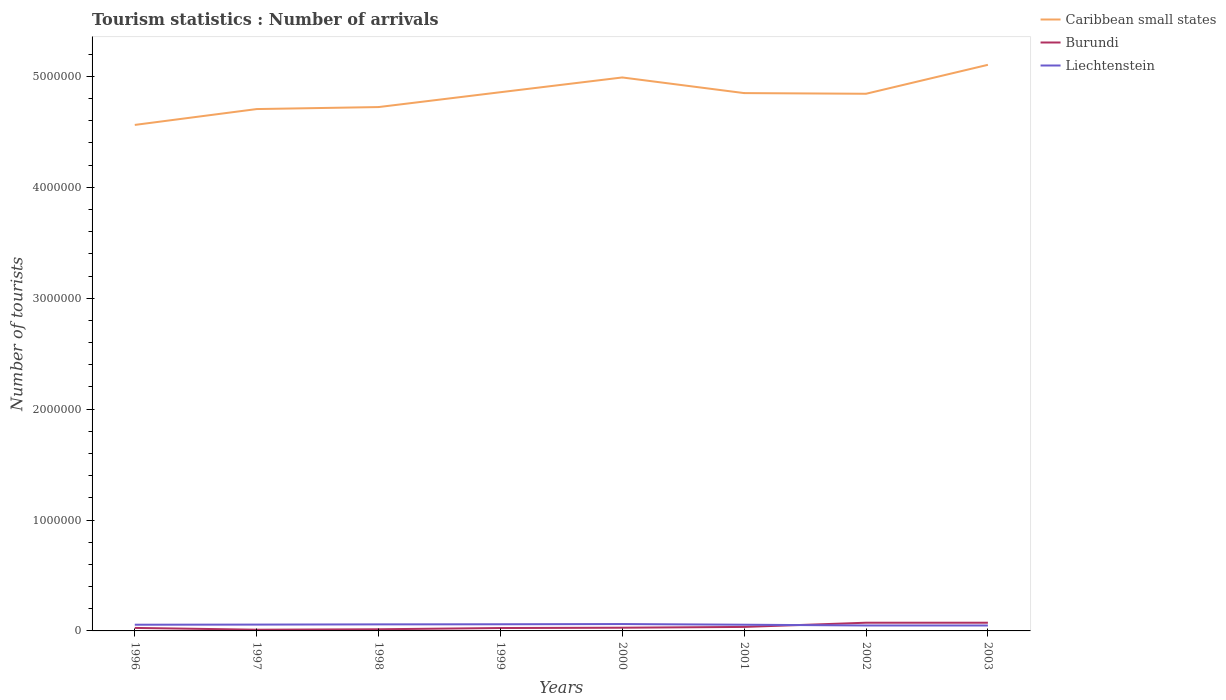How many different coloured lines are there?
Provide a short and direct response. 3. Does the line corresponding to Liechtenstein intersect with the line corresponding to Burundi?
Your answer should be compact. Yes. Across all years, what is the maximum number of tourist arrivals in Caribbean small states?
Provide a succinct answer. 4.56e+06. In which year was the number of tourist arrivals in Burundi maximum?
Provide a short and direct response. 1997. What is the total number of tourist arrivals in Burundi in the graph?
Give a very brief answer. -2000. What is the difference between the highest and the second highest number of tourist arrivals in Liechtenstein?
Offer a terse response. 1.30e+04. How many years are there in the graph?
Ensure brevity in your answer.  8. Does the graph contain grids?
Make the answer very short. No. Where does the legend appear in the graph?
Your answer should be compact. Top right. How many legend labels are there?
Offer a terse response. 3. How are the legend labels stacked?
Offer a very short reply. Vertical. What is the title of the graph?
Provide a succinct answer. Tourism statistics : Number of arrivals. Does "Comoros" appear as one of the legend labels in the graph?
Ensure brevity in your answer.  No. What is the label or title of the Y-axis?
Make the answer very short. Number of tourists. What is the Number of tourists of Caribbean small states in 1996?
Keep it short and to the point. 4.56e+06. What is the Number of tourists in Burundi in 1996?
Your answer should be very brief. 2.70e+04. What is the Number of tourists of Liechtenstein in 1996?
Offer a terse response. 5.60e+04. What is the Number of tourists of Caribbean small states in 1997?
Offer a very short reply. 4.71e+06. What is the Number of tourists in Burundi in 1997?
Ensure brevity in your answer.  1.10e+04. What is the Number of tourists in Liechtenstein in 1997?
Provide a succinct answer. 5.70e+04. What is the Number of tourists in Caribbean small states in 1998?
Offer a terse response. 4.72e+06. What is the Number of tourists in Burundi in 1998?
Your response must be concise. 1.50e+04. What is the Number of tourists in Liechtenstein in 1998?
Your response must be concise. 5.90e+04. What is the Number of tourists of Caribbean small states in 1999?
Your response must be concise. 4.86e+06. What is the Number of tourists in Burundi in 1999?
Make the answer very short. 2.60e+04. What is the Number of tourists of Liechtenstein in 1999?
Provide a succinct answer. 6.00e+04. What is the Number of tourists in Caribbean small states in 2000?
Make the answer very short. 4.99e+06. What is the Number of tourists in Burundi in 2000?
Provide a short and direct response. 2.90e+04. What is the Number of tourists in Liechtenstein in 2000?
Give a very brief answer. 6.20e+04. What is the Number of tourists in Caribbean small states in 2001?
Your response must be concise. 4.85e+06. What is the Number of tourists of Burundi in 2001?
Provide a succinct answer. 3.60e+04. What is the Number of tourists in Liechtenstein in 2001?
Keep it short and to the point. 5.60e+04. What is the Number of tourists in Caribbean small states in 2002?
Provide a short and direct response. 4.84e+06. What is the Number of tourists of Burundi in 2002?
Offer a terse response. 7.40e+04. What is the Number of tourists in Liechtenstein in 2002?
Your answer should be compact. 4.90e+04. What is the Number of tourists of Caribbean small states in 2003?
Provide a short and direct response. 5.10e+06. What is the Number of tourists of Burundi in 2003?
Provide a short and direct response. 7.40e+04. What is the Number of tourists in Liechtenstein in 2003?
Give a very brief answer. 4.90e+04. Across all years, what is the maximum Number of tourists of Caribbean small states?
Ensure brevity in your answer.  5.10e+06. Across all years, what is the maximum Number of tourists in Burundi?
Provide a short and direct response. 7.40e+04. Across all years, what is the maximum Number of tourists in Liechtenstein?
Offer a terse response. 6.20e+04. Across all years, what is the minimum Number of tourists of Caribbean small states?
Your answer should be very brief. 4.56e+06. Across all years, what is the minimum Number of tourists in Burundi?
Keep it short and to the point. 1.10e+04. Across all years, what is the minimum Number of tourists in Liechtenstein?
Give a very brief answer. 4.90e+04. What is the total Number of tourists of Caribbean small states in the graph?
Give a very brief answer. 3.86e+07. What is the total Number of tourists in Burundi in the graph?
Offer a very short reply. 2.92e+05. What is the total Number of tourists in Liechtenstein in the graph?
Give a very brief answer. 4.48e+05. What is the difference between the Number of tourists in Caribbean small states in 1996 and that in 1997?
Offer a terse response. -1.43e+05. What is the difference between the Number of tourists in Burundi in 1996 and that in 1997?
Your response must be concise. 1.60e+04. What is the difference between the Number of tourists in Liechtenstein in 1996 and that in 1997?
Provide a succinct answer. -1000. What is the difference between the Number of tourists in Caribbean small states in 1996 and that in 1998?
Offer a very short reply. -1.61e+05. What is the difference between the Number of tourists of Burundi in 1996 and that in 1998?
Provide a succinct answer. 1.20e+04. What is the difference between the Number of tourists in Liechtenstein in 1996 and that in 1998?
Give a very brief answer. -3000. What is the difference between the Number of tourists of Caribbean small states in 1996 and that in 1999?
Your response must be concise. -2.95e+05. What is the difference between the Number of tourists of Burundi in 1996 and that in 1999?
Keep it short and to the point. 1000. What is the difference between the Number of tourists of Liechtenstein in 1996 and that in 1999?
Provide a short and direct response. -4000. What is the difference between the Number of tourists of Caribbean small states in 1996 and that in 2000?
Give a very brief answer. -4.28e+05. What is the difference between the Number of tourists of Burundi in 1996 and that in 2000?
Make the answer very short. -2000. What is the difference between the Number of tourists of Liechtenstein in 1996 and that in 2000?
Your response must be concise. -6000. What is the difference between the Number of tourists of Caribbean small states in 1996 and that in 2001?
Give a very brief answer. -2.87e+05. What is the difference between the Number of tourists of Burundi in 1996 and that in 2001?
Keep it short and to the point. -9000. What is the difference between the Number of tourists in Caribbean small states in 1996 and that in 2002?
Give a very brief answer. -2.81e+05. What is the difference between the Number of tourists of Burundi in 1996 and that in 2002?
Ensure brevity in your answer.  -4.70e+04. What is the difference between the Number of tourists of Liechtenstein in 1996 and that in 2002?
Provide a succinct answer. 7000. What is the difference between the Number of tourists of Caribbean small states in 1996 and that in 2003?
Ensure brevity in your answer.  -5.42e+05. What is the difference between the Number of tourists in Burundi in 1996 and that in 2003?
Provide a succinct answer. -4.70e+04. What is the difference between the Number of tourists of Liechtenstein in 1996 and that in 2003?
Provide a succinct answer. 7000. What is the difference between the Number of tourists of Caribbean small states in 1997 and that in 1998?
Keep it short and to the point. -1.80e+04. What is the difference between the Number of tourists in Burundi in 1997 and that in 1998?
Your response must be concise. -4000. What is the difference between the Number of tourists in Liechtenstein in 1997 and that in 1998?
Provide a succinct answer. -2000. What is the difference between the Number of tourists in Caribbean small states in 1997 and that in 1999?
Offer a terse response. -1.52e+05. What is the difference between the Number of tourists in Burundi in 1997 and that in 1999?
Make the answer very short. -1.50e+04. What is the difference between the Number of tourists of Liechtenstein in 1997 and that in 1999?
Keep it short and to the point. -3000. What is the difference between the Number of tourists in Caribbean small states in 1997 and that in 2000?
Keep it short and to the point. -2.85e+05. What is the difference between the Number of tourists in Burundi in 1997 and that in 2000?
Make the answer very short. -1.80e+04. What is the difference between the Number of tourists of Liechtenstein in 1997 and that in 2000?
Your response must be concise. -5000. What is the difference between the Number of tourists in Caribbean small states in 1997 and that in 2001?
Offer a terse response. -1.44e+05. What is the difference between the Number of tourists in Burundi in 1997 and that in 2001?
Offer a terse response. -2.50e+04. What is the difference between the Number of tourists in Caribbean small states in 1997 and that in 2002?
Offer a very short reply. -1.38e+05. What is the difference between the Number of tourists of Burundi in 1997 and that in 2002?
Give a very brief answer. -6.30e+04. What is the difference between the Number of tourists of Liechtenstein in 1997 and that in 2002?
Give a very brief answer. 8000. What is the difference between the Number of tourists in Caribbean small states in 1997 and that in 2003?
Your answer should be compact. -3.99e+05. What is the difference between the Number of tourists of Burundi in 1997 and that in 2003?
Make the answer very short. -6.30e+04. What is the difference between the Number of tourists in Liechtenstein in 1997 and that in 2003?
Your answer should be very brief. 8000. What is the difference between the Number of tourists of Caribbean small states in 1998 and that in 1999?
Your answer should be compact. -1.34e+05. What is the difference between the Number of tourists of Burundi in 1998 and that in 1999?
Provide a succinct answer. -1.10e+04. What is the difference between the Number of tourists in Liechtenstein in 1998 and that in 1999?
Ensure brevity in your answer.  -1000. What is the difference between the Number of tourists in Caribbean small states in 1998 and that in 2000?
Give a very brief answer. -2.67e+05. What is the difference between the Number of tourists of Burundi in 1998 and that in 2000?
Give a very brief answer. -1.40e+04. What is the difference between the Number of tourists of Liechtenstein in 1998 and that in 2000?
Your response must be concise. -3000. What is the difference between the Number of tourists of Caribbean small states in 1998 and that in 2001?
Your response must be concise. -1.26e+05. What is the difference between the Number of tourists in Burundi in 1998 and that in 2001?
Give a very brief answer. -2.10e+04. What is the difference between the Number of tourists of Liechtenstein in 1998 and that in 2001?
Your response must be concise. 3000. What is the difference between the Number of tourists of Burundi in 1998 and that in 2002?
Provide a short and direct response. -5.90e+04. What is the difference between the Number of tourists of Liechtenstein in 1998 and that in 2002?
Make the answer very short. 10000. What is the difference between the Number of tourists in Caribbean small states in 1998 and that in 2003?
Provide a short and direct response. -3.81e+05. What is the difference between the Number of tourists in Burundi in 1998 and that in 2003?
Your response must be concise. -5.90e+04. What is the difference between the Number of tourists in Caribbean small states in 1999 and that in 2000?
Offer a very short reply. -1.33e+05. What is the difference between the Number of tourists in Burundi in 1999 and that in 2000?
Offer a very short reply. -3000. What is the difference between the Number of tourists in Liechtenstein in 1999 and that in 2000?
Provide a short and direct response. -2000. What is the difference between the Number of tourists of Caribbean small states in 1999 and that in 2001?
Ensure brevity in your answer.  8000. What is the difference between the Number of tourists of Liechtenstein in 1999 and that in 2001?
Offer a terse response. 4000. What is the difference between the Number of tourists of Caribbean small states in 1999 and that in 2002?
Offer a terse response. 1.40e+04. What is the difference between the Number of tourists of Burundi in 1999 and that in 2002?
Make the answer very short. -4.80e+04. What is the difference between the Number of tourists in Liechtenstein in 1999 and that in 2002?
Your answer should be compact. 1.10e+04. What is the difference between the Number of tourists of Caribbean small states in 1999 and that in 2003?
Offer a terse response. -2.47e+05. What is the difference between the Number of tourists of Burundi in 1999 and that in 2003?
Provide a succinct answer. -4.80e+04. What is the difference between the Number of tourists in Liechtenstein in 1999 and that in 2003?
Provide a succinct answer. 1.10e+04. What is the difference between the Number of tourists of Caribbean small states in 2000 and that in 2001?
Give a very brief answer. 1.41e+05. What is the difference between the Number of tourists of Burundi in 2000 and that in 2001?
Ensure brevity in your answer.  -7000. What is the difference between the Number of tourists of Liechtenstein in 2000 and that in 2001?
Make the answer very short. 6000. What is the difference between the Number of tourists of Caribbean small states in 2000 and that in 2002?
Provide a short and direct response. 1.47e+05. What is the difference between the Number of tourists of Burundi in 2000 and that in 2002?
Make the answer very short. -4.50e+04. What is the difference between the Number of tourists in Liechtenstein in 2000 and that in 2002?
Make the answer very short. 1.30e+04. What is the difference between the Number of tourists in Caribbean small states in 2000 and that in 2003?
Your response must be concise. -1.14e+05. What is the difference between the Number of tourists of Burundi in 2000 and that in 2003?
Your answer should be very brief. -4.50e+04. What is the difference between the Number of tourists of Liechtenstein in 2000 and that in 2003?
Offer a very short reply. 1.30e+04. What is the difference between the Number of tourists of Caribbean small states in 2001 and that in 2002?
Ensure brevity in your answer.  6000. What is the difference between the Number of tourists of Burundi in 2001 and that in 2002?
Provide a succinct answer. -3.80e+04. What is the difference between the Number of tourists in Liechtenstein in 2001 and that in 2002?
Keep it short and to the point. 7000. What is the difference between the Number of tourists of Caribbean small states in 2001 and that in 2003?
Give a very brief answer. -2.55e+05. What is the difference between the Number of tourists in Burundi in 2001 and that in 2003?
Your answer should be very brief. -3.80e+04. What is the difference between the Number of tourists of Liechtenstein in 2001 and that in 2003?
Ensure brevity in your answer.  7000. What is the difference between the Number of tourists of Caribbean small states in 2002 and that in 2003?
Provide a short and direct response. -2.61e+05. What is the difference between the Number of tourists of Burundi in 2002 and that in 2003?
Make the answer very short. 0. What is the difference between the Number of tourists in Caribbean small states in 1996 and the Number of tourists in Burundi in 1997?
Your answer should be very brief. 4.55e+06. What is the difference between the Number of tourists in Caribbean small states in 1996 and the Number of tourists in Liechtenstein in 1997?
Provide a succinct answer. 4.51e+06. What is the difference between the Number of tourists in Caribbean small states in 1996 and the Number of tourists in Burundi in 1998?
Keep it short and to the point. 4.55e+06. What is the difference between the Number of tourists of Caribbean small states in 1996 and the Number of tourists of Liechtenstein in 1998?
Your answer should be very brief. 4.50e+06. What is the difference between the Number of tourists of Burundi in 1996 and the Number of tourists of Liechtenstein in 1998?
Provide a short and direct response. -3.20e+04. What is the difference between the Number of tourists in Caribbean small states in 1996 and the Number of tourists in Burundi in 1999?
Offer a very short reply. 4.54e+06. What is the difference between the Number of tourists in Caribbean small states in 1996 and the Number of tourists in Liechtenstein in 1999?
Offer a terse response. 4.50e+06. What is the difference between the Number of tourists of Burundi in 1996 and the Number of tourists of Liechtenstein in 1999?
Your response must be concise. -3.30e+04. What is the difference between the Number of tourists of Caribbean small states in 1996 and the Number of tourists of Burundi in 2000?
Your response must be concise. 4.53e+06. What is the difference between the Number of tourists in Caribbean small states in 1996 and the Number of tourists in Liechtenstein in 2000?
Ensure brevity in your answer.  4.50e+06. What is the difference between the Number of tourists in Burundi in 1996 and the Number of tourists in Liechtenstein in 2000?
Your response must be concise. -3.50e+04. What is the difference between the Number of tourists in Caribbean small states in 1996 and the Number of tourists in Burundi in 2001?
Your response must be concise. 4.53e+06. What is the difference between the Number of tourists in Caribbean small states in 1996 and the Number of tourists in Liechtenstein in 2001?
Your response must be concise. 4.51e+06. What is the difference between the Number of tourists in Burundi in 1996 and the Number of tourists in Liechtenstein in 2001?
Your answer should be very brief. -2.90e+04. What is the difference between the Number of tourists of Caribbean small states in 1996 and the Number of tourists of Burundi in 2002?
Keep it short and to the point. 4.49e+06. What is the difference between the Number of tourists of Caribbean small states in 1996 and the Number of tourists of Liechtenstein in 2002?
Ensure brevity in your answer.  4.51e+06. What is the difference between the Number of tourists of Burundi in 1996 and the Number of tourists of Liechtenstein in 2002?
Provide a succinct answer. -2.20e+04. What is the difference between the Number of tourists of Caribbean small states in 1996 and the Number of tourists of Burundi in 2003?
Ensure brevity in your answer.  4.49e+06. What is the difference between the Number of tourists in Caribbean small states in 1996 and the Number of tourists in Liechtenstein in 2003?
Provide a succinct answer. 4.51e+06. What is the difference between the Number of tourists of Burundi in 1996 and the Number of tourists of Liechtenstein in 2003?
Your response must be concise. -2.20e+04. What is the difference between the Number of tourists in Caribbean small states in 1997 and the Number of tourists in Burundi in 1998?
Provide a succinct answer. 4.69e+06. What is the difference between the Number of tourists of Caribbean small states in 1997 and the Number of tourists of Liechtenstein in 1998?
Give a very brief answer. 4.65e+06. What is the difference between the Number of tourists in Burundi in 1997 and the Number of tourists in Liechtenstein in 1998?
Provide a succinct answer. -4.80e+04. What is the difference between the Number of tourists in Caribbean small states in 1997 and the Number of tourists in Burundi in 1999?
Your answer should be very brief. 4.68e+06. What is the difference between the Number of tourists in Caribbean small states in 1997 and the Number of tourists in Liechtenstein in 1999?
Your answer should be compact. 4.65e+06. What is the difference between the Number of tourists in Burundi in 1997 and the Number of tourists in Liechtenstein in 1999?
Provide a succinct answer. -4.90e+04. What is the difference between the Number of tourists in Caribbean small states in 1997 and the Number of tourists in Burundi in 2000?
Offer a terse response. 4.68e+06. What is the difference between the Number of tourists in Caribbean small states in 1997 and the Number of tourists in Liechtenstein in 2000?
Make the answer very short. 4.64e+06. What is the difference between the Number of tourists of Burundi in 1997 and the Number of tourists of Liechtenstein in 2000?
Offer a very short reply. -5.10e+04. What is the difference between the Number of tourists of Caribbean small states in 1997 and the Number of tourists of Burundi in 2001?
Ensure brevity in your answer.  4.67e+06. What is the difference between the Number of tourists of Caribbean small states in 1997 and the Number of tourists of Liechtenstein in 2001?
Give a very brief answer. 4.65e+06. What is the difference between the Number of tourists of Burundi in 1997 and the Number of tourists of Liechtenstein in 2001?
Ensure brevity in your answer.  -4.50e+04. What is the difference between the Number of tourists in Caribbean small states in 1997 and the Number of tourists in Burundi in 2002?
Your answer should be very brief. 4.63e+06. What is the difference between the Number of tourists in Caribbean small states in 1997 and the Number of tourists in Liechtenstein in 2002?
Offer a terse response. 4.66e+06. What is the difference between the Number of tourists in Burundi in 1997 and the Number of tourists in Liechtenstein in 2002?
Provide a short and direct response. -3.80e+04. What is the difference between the Number of tourists of Caribbean small states in 1997 and the Number of tourists of Burundi in 2003?
Give a very brief answer. 4.63e+06. What is the difference between the Number of tourists in Caribbean small states in 1997 and the Number of tourists in Liechtenstein in 2003?
Your answer should be compact. 4.66e+06. What is the difference between the Number of tourists in Burundi in 1997 and the Number of tourists in Liechtenstein in 2003?
Provide a succinct answer. -3.80e+04. What is the difference between the Number of tourists of Caribbean small states in 1998 and the Number of tourists of Burundi in 1999?
Your response must be concise. 4.70e+06. What is the difference between the Number of tourists in Caribbean small states in 1998 and the Number of tourists in Liechtenstein in 1999?
Your answer should be compact. 4.66e+06. What is the difference between the Number of tourists of Burundi in 1998 and the Number of tourists of Liechtenstein in 1999?
Keep it short and to the point. -4.50e+04. What is the difference between the Number of tourists of Caribbean small states in 1998 and the Number of tourists of Burundi in 2000?
Keep it short and to the point. 4.70e+06. What is the difference between the Number of tourists of Caribbean small states in 1998 and the Number of tourists of Liechtenstein in 2000?
Provide a short and direct response. 4.66e+06. What is the difference between the Number of tourists in Burundi in 1998 and the Number of tourists in Liechtenstein in 2000?
Give a very brief answer. -4.70e+04. What is the difference between the Number of tourists of Caribbean small states in 1998 and the Number of tourists of Burundi in 2001?
Make the answer very short. 4.69e+06. What is the difference between the Number of tourists of Caribbean small states in 1998 and the Number of tourists of Liechtenstein in 2001?
Give a very brief answer. 4.67e+06. What is the difference between the Number of tourists of Burundi in 1998 and the Number of tourists of Liechtenstein in 2001?
Your response must be concise. -4.10e+04. What is the difference between the Number of tourists in Caribbean small states in 1998 and the Number of tourists in Burundi in 2002?
Give a very brief answer. 4.65e+06. What is the difference between the Number of tourists of Caribbean small states in 1998 and the Number of tourists of Liechtenstein in 2002?
Give a very brief answer. 4.68e+06. What is the difference between the Number of tourists in Burundi in 1998 and the Number of tourists in Liechtenstein in 2002?
Make the answer very short. -3.40e+04. What is the difference between the Number of tourists in Caribbean small states in 1998 and the Number of tourists in Burundi in 2003?
Your response must be concise. 4.65e+06. What is the difference between the Number of tourists of Caribbean small states in 1998 and the Number of tourists of Liechtenstein in 2003?
Your answer should be very brief. 4.68e+06. What is the difference between the Number of tourists in Burundi in 1998 and the Number of tourists in Liechtenstein in 2003?
Your answer should be very brief. -3.40e+04. What is the difference between the Number of tourists in Caribbean small states in 1999 and the Number of tourists in Burundi in 2000?
Make the answer very short. 4.83e+06. What is the difference between the Number of tourists of Caribbean small states in 1999 and the Number of tourists of Liechtenstein in 2000?
Your answer should be very brief. 4.80e+06. What is the difference between the Number of tourists in Burundi in 1999 and the Number of tourists in Liechtenstein in 2000?
Offer a very short reply. -3.60e+04. What is the difference between the Number of tourists of Caribbean small states in 1999 and the Number of tourists of Burundi in 2001?
Your answer should be compact. 4.82e+06. What is the difference between the Number of tourists of Caribbean small states in 1999 and the Number of tourists of Liechtenstein in 2001?
Make the answer very short. 4.80e+06. What is the difference between the Number of tourists in Caribbean small states in 1999 and the Number of tourists in Burundi in 2002?
Provide a succinct answer. 4.78e+06. What is the difference between the Number of tourists in Caribbean small states in 1999 and the Number of tourists in Liechtenstein in 2002?
Your answer should be compact. 4.81e+06. What is the difference between the Number of tourists of Burundi in 1999 and the Number of tourists of Liechtenstein in 2002?
Provide a short and direct response. -2.30e+04. What is the difference between the Number of tourists in Caribbean small states in 1999 and the Number of tourists in Burundi in 2003?
Your response must be concise. 4.78e+06. What is the difference between the Number of tourists of Caribbean small states in 1999 and the Number of tourists of Liechtenstein in 2003?
Give a very brief answer. 4.81e+06. What is the difference between the Number of tourists of Burundi in 1999 and the Number of tourists of Liechtenstein in 2003?
Provide a succinct answer. -2.30e+04. What is the difference between the Number of tourists of Caribbean small states in 2000 and the Number of tourists of Burundi in 2001?
Your answer should be compact. 4.96e+06. What is the difference between the Number of tourists of Caribbean small states in 2000 and the Number of tourists of Liechtenstein in 2001?
Keep it short and to the point. 4.94e+06. What is the difference between the Number of tourists in Burundi in 2000 and the Number of tourists in Liechtenstein in 2001?
Provide a succinct answer. -2.70e+04. What is the difference between the Number of tourists in Caribbean small states in 2000 and the Number of tourists in Burundi in 2002?
Your answer should be very brief. 4.92e+06. What is the difference between the Number of tourists of Caribbean small states in 2000 and the Number of tourists of Liechtenstein in 2002?
Make the answer very short. 4.94e+06. What is the difference between the Number of tourists in Caribbean small states in 2000 and the Number of tourists in Burundi in 2003?
Provide a short and direct response. 4.92e+06. What is the difference between the Number of tourists in Caribbean small states in 2000 and the Number of tourists in Liechtenstein in 2003?
Provide a short and direct response. 4.94e+06. What is the difference between the Number of tourists of Caribbean small states in 2001 and the Number of tourists of Burundi in 2002?
Make the answer very short. 4.78e+06. What is the difference between the Number of tourists of Caribbean small states in 2001 and the Number of tourists of Liechtenstein in 2002?
Make the answer very short. 4.80e+06. What is the difference between the Number of tourists of Burundi in 2001 and the Number of tourists of Liechtenstein in 2002?
Offer a terse response. -1.30e+04. What is the difference between the Number of tourists in Caribbean small states in 2001 and the Number of tourists in Burundi in 2003?
Ensure brevity in your answer.  4.78e+06. What is the difference between the Number of tourists of Caribbean small states in 2001 and the Number of tourists of Liechtenstein in 2003?
Provide a short and direct response. 4.80e+06. What is the difference between the Number of tourists of Burundi in 2001 and the Number of tourists of Liechtenstein in 2003?
Your answer should be compact. -1.30e+04. What is the difference between the Number of tourists of Caribbean small states in 2002 and the Number of tourists of Burundi in 2003?
Your answer should be very brief. 4.77e+06. What is the difference between the Number of tourists in Caribbean small states in 2002 and the Number of tourists in Liechtenstein in 2003?
Your answer should be very brief. 4.80e+06. What is the difference between the Number of tourists of Burundi in 2002 and the Number of tourists of Liechtenstein in 2003?
Your answer should be compact. 2.50e+04. What is the average Number of tourists of Caribbean small states per year?
Give a very brief answer. 4.83e+06. What is the average Number of tourists in Burundi per year?
Provide a short and direct response. 3.65e+04. What is the average Number of tourists in Liechtenstein per year?
Provide a short and direct response. 5.60e+04. In the year 1996, what is the difference between the Number of tourists of Caribbean small states and Number of tourists of Burundi?
Your answer should be compact. 4.54e+06. In the year 1996, what is the difference between the Number of tourists in Caribbean small states and Number of tourists in Liechtenstein?
Your response must be concise. 4.51e+06. In the year 1996, what is the difference between the Number of tourists of Burundi and Number of tourists of Liechtenstein?
Ensure brevity in your answer.  -2.90e+04. In the year 1997, what is the difference between the Number of tourists of Caribbean small states and Number of tourists of Burundi?
Your answer should be very brief. 4.70e+06. In the year 1997, what is the difference between the Number of tourists of Caribbean small states and Number of tourists of Liechtenstein?
Provide a succinct answer. 4.65e+06. In the year 1997, what is the difference between the Number of tourists of Burundi and Number of tourists of Liechtenstein?
Provide a succinct answer. -4.60e+04. In the year 1998, what is the difference between the Number of tourists in Caribbean small states and Number of tourists in Burundi?
Offer a very short reply. 4.71e+06. In the year 1998, what is the difference between the Number of tourists in Caribbean small states and Number of tourists in Liechtenstein?
Provide a succinct answer. 4.66e+06. In the year 1998, what is the difference between the Number of tourists of Burundi and Number of tourists of Liechtenstein?
Provide a short and direct response. -4.40e+04. In the year 1999, what is the difference between the Number of tourists in Caribbean small states and Number of tourists in Burundi?
Offer a terse response. 4.83e+06. In the year 1999, what is the difference between the Number of tourists in Caribbean small states and Number of tourists in Liechtenstein?
Make the answer very short. 4.80e+06. In the year 1999, what is the difference between the Number of tourists of Burundi and Number of tourists of Liechtenstein?
Give a very brief answer. -3.40e+04. In the year 2000, what is the difference between the Number of tourists of Caribbean small states and Number of tourists of Burundi?
Your answer should be compact. 4.96e+06. In the year 2000, what is the difference between the Number of tourists in Caribbean small states and Number of tourists in Liechtenstein?
Give a very brief answer. 4.93e+06. In the year 2000, what is the difference between the Number of tourists of Burundi and Number of tourists of Liechtenstein?
Offer a terse response. -3.30e+04. In the year 2001, what is the difference between the Number of tourists of Caribbean small states and Number of tourists of Burundi?
Provide a short and direct response. 4.81e+06. In the year 2001, what is the difference between the Number of tourists in Caribbean small states and Number of tourists in Liechtenstein?
Your answer should be very brief. 4.79e+06. In the year 2002, what is the difference between the Number of tourists in Caribbean small states and Number of tourists in Burundi?
Provide a succinct answer. 4.77e+06. In the year 2002, what is the difference between the Number of tourists in Caribbean small states and Number of tourists in Liechtenstein?
Your response must be concise. 4.80e+06. In the year 2002, what is the difference between the Number of tourists of Burundi and Number of tourists of Liechtenstein?
Keep it short and to the point. 2.50e+04. In the year 2003, what is the difference between the Number of tourists of Caribbean small states and Number of tourists of Burundi?
Your answer should be very brief. 5.03e+06. In the year 2003, what is the difference between the Number of tourists of Caribbean small states and Number of tourists of Liechtenstein?
Keep it short and to the point. 5.06e+06. In the year 2003, what is the difference between the Number of tourists of Burundi and Number of tourists of Liechtenstein?
Ensure brevity in your answer.  2.50e+04. What is the ratio of the Number of tourists of Caribbean small states in 1996 to that in 1997?
Your answer should be very brief. 0.97. What is the ratio of the Number of tourists in Burundi in 1996 to that in 1997?
Keep it short and to the point. 2.45. What is the ratio of the Number of tourists of Liechtenstein in 1996 to that in 1997?
Your answer should be compact. 0.98. What is the ratio of the Number of tourists in Caribbean small states in 1996 to that in 1998?
Offer a very short reply. 0.97. What is the ratio of the Number of tourists of Liechtenstein in 1996 to that in 1998?
Give a very brief answer. 0.95. What is the ratio of the Number of tourists in Caribbean small states in 1996 to that in 1999?
Ensure brevity in your answer.  0.94. What is the ratio of the Number of tourists of Caribbean small states in 1996 to that in 2000?
Your answer should be compact. 0.91. What is the ratio of the Number of tourists of Burundi in 1996 to that in 2000?
Your response must be concise. 0.93. What is the ratio of the Number of tourists in Liechtenstein in 1996 to that in 2000?
Provide a short and direct response. 0.9. What is the ratio of the Number of tourists in Caribbean small states in 1996 to that in 2001?
Offer a very short reply. 0.94. What is the ratio of the Number of tourists of Caribbean small states in 1996 to that in 2002?
Offer a terse response. 0.94. What is the ratio of the Number of tourists of Burundi in 1996 to that in 2002?
Ensure brevity in your answer.  0.36. What is the ratio of the Number of tourists in Liechtenstein in 1996 to that in 2002?
Keep it short and to the point. 1.14. What is the ratio of the Number of tourists in Caribbean small states in 1996 to that in 2003?
Your answer should be compact. 0.89. What is the ratio of the Number of tourists in Burundi in 1996 to that in 2003?
Your response must be concise. 0.36. What is the ratio of the Number of tourists in Liechtenstein in 1996 to that in 2003?
Offer a very short reply. 1.14. What is the ratio of the Number of tourists in Burundi in 1997 to that in 1998?
Keep it short and to the point. 0.73. What is the ratio of the Number of tourists in Liechtenstein in 1997 to that in 1998?
Give a very brief answer. 0.97. What is the ratio of the Number of tourists in Caribbean small states in 1997 to that in 1999?
Offer a terse response. 0.97. What is the ratio of the Number of tourists in Burundi in 1997 to that in 1999?
Give a very brief answer. 0.42. What is the ratio of the Number of tourists of Liechtenstein in 1997 to that in 1999?
Give a very brief answer. 0.95. What is the ratio of the Number of tourists in Caribbean small states in 1997 to that in 2000?
Your answer should be compact. 0.94. What is the ratio of the Number of tourists of Burundi in 1997 to that in 2000?
Your answer should be very brief. 0.38. What is the ratio of the Number of tourists of Liechtenstein in 1997 to that in 2000?
Your answer should be compact. 0.92. What is the ratio of the Number of tourists in Caribbean small states in 1997 to that in 2001?
Provide a short and direct response. 0.97. What is the ratio of the Number of tourists in Burundi in 1997 to that in 2001?
Provide a short and direct response. 0.31. What is the ratio of the Number of tourists of Liechtenstein in 1997 to that in 2001?
Give a very brief answer. 1.02. What is the ratio of the Number of tourists of Caribbean small states in 1997 to that in 2002?
Offer a very short reply. 0.97. What is the ratio of the Number of tourists of Burundi in 1997 to that in 2002?
Provide a succinct answer. 0.15. What is the ratio of the Number of tourists in Liechtenstein in 1997 to that in 2002?
Offer a terse response. 1.16. What is the ratio of the Number of tourists in Caribbean small states in 1997 to that in 2003?
Offer a very short reply. 0.92. What is the ratio of the Number of tourists in Burundi in 1997 to that in 2003?
Your answer should be compact. 0.15. What is the ratio of the Number of tourists in Liechtenstein in 1997 to that in 2003?
Ensure brevity in your answer.  1.16. What is the ratio of the Number of tourists of Caribbean small states in 1998 to that in 1999?
Your answer should be very brief. 0.97. What is the ratio of the Number of tourists in Burundi in 1998 to that in 1999?
Offer a very short reply. 0.58. What is the ratio of the Number of tourists in Liechtenstein in 1998 to that in 1999?
Provide a succinct answer. 0.98. What is the ratio of the Number of tourists of Caribbean small states in 1998 to that in 2000?
Your answer should be very brief. 0.95. What is the ratio of the Number of tourists in Burundi in 1998 to that in 2000?
Your response must be concise. 0.52. What is the ratio of the Number of tourists in Liechtenstein in 1998 to that in 2000?
Offer a terse response. 0.95. What is the ratio of the Number of tourists in Burundi in 1998 to that in 2001?
Provide a short and direct response. 0.42. What is the ratio of the Number of tourists in Liechtenstein in 1998 to that in 2001?
Provide a short and direct response. 1.05. What is the ratio of the Number of tourists in Caribbean small states in 1998 to that in 2002?
Make the answer very short. 0.98. What is the ratio of the Number of tourists in Burundi in 1998 to that in 2002?
Your answer should be compact. 0.2. What is the ratio of the Number of tourists of Liechtenstein in 1998 to that in 2002?
Your response must be concise. 1.2. What is the ratio of the Number of tourists in Caribbean small states in 1998 to that in 2003?
Your answer should be very brief. 0.93. What is the ratio of the Number of tourists of Burundi in 1998 to that in 2003?
Your response must be concise. 0.2. What is the ratio of the Number of tourists of Liechtenstein in 1998 to that in 2003?
Give a very brief answer. 1.2. What is the ratio of the Number of tourists of Caribbean small states in 1999 to that in 2000?
Ensure brevity in your answer.  0.97. What is the ratio of the Number of tourists in Burundi in 1999 to that in 2000?
Give a very brief answer. 0.9. What is the ratio of the Number of tourists in Liechtenstein in 1999 to that in 2000?
Provide a succinct answer. 0.97. What is the ratio of the Number of tourists in Burundi in 1999 to that in 2001?
Your answer should be compact. 0.72. What is the ratio of the Number of tourists of Liechtenstein in 1999 to that in 2001?
Provide a short and direct response. 1.07. What is the ratio of the Number of tourists of Burundi in 1999 to that in 2002?
Make the answer very short. 0.35. What is the ratio of the Number of tourists in Liechtenstein in 1999 to that in 2002?
Your response must be concise. 1.22. What is the ratio of the Number of tourists of Caribbean small states in 1999 to that in 2003?
Your response must be concise. 0.95. What is the ratio of the Number of tourists of Burundi in 1999 to that in 2003?
Make the answer very short. 0.35. What is the ratio of the Number of tourists in Liechtenstein in 1999 to that in 2003?
Your answer should be compact. 1.22. What is the ratio of the Number of tourists of Caribbean small states in 2000 to that in 2001?
Ensure brevity in your answer.  1.03. What is the ratio of the Number of tourists of Burundi in 2000 to that in 2001?
Keep it short and to the point. 0.81. What is the ratio of the Number of tourists of Liechtenstein in 2000 to that in 2001?
Give a very brief answer. 1.11. What is the ratio of the Number of tourists of Caribbean small states in 2000 to that in 2002?
Ensure brevity in your answer.  1.03. What is the ratio of the Number of tourists in Burundi in 2000 to that in 2002?
Your answer should be compact. 0.39. What is the ratio of the Number of tourists in Liechtenstein in 2000 to that in 2002?
Make the answer very short. 1.27. What is the ratio of the Number of tourists of Caribbean small states in 2000 to that in 2003?
Provide a short and direct response. 0.98. What is the ratio of the Number of tourists of Burundi in 2000 to that in 2003?
Give a very brief answer. 0.39. What is the ratio of the Number of tourists of Liechtenstein in 2000 to that in 2003?
Offer a very short reply. 1.27. What is the ratio of the Number of tourists in Burundi in 2001 to that in 2002?
Provide a short and direct response. 0.49. What is the ratio of the Number of tourists in Burundi in 2001 to that in 2003?
Give a very brief answer. 0.49. What is the ratio of the Number of tourists in Liechtenstein in 2001 to that in 2003?
Keep it short and to the point. 1.14. What is the ratio of the Number of tourists of Caribbean small states in 2002 to that in 2003?
Your answer should be compact. 0.95. What is the ratio of the Number of tourists in Burundi in 2002 to that in 2003?
Provide a short and direct response. 1. What is the ratio of the Number of tourists of Liechtenstein in 2002 to that in 2003?
Your answer should be very brief. 1. What is the difference between the highest and the second highest Number of tourists of Caribbean small states?
Your answer should be very brief. 1.14e+05. What is the difference between the highest and the second highest Number of tourists of Liechtenstein?
Provide a short and direct response. 2000. What is the difference between the highest and the lowest Number of tourists in Caribbean small states?
Provide a short and direct response. 5.42e+05. What is the difference between the highest and the lowest Number of tourists of Burundi?
Make the answer very short. 6.30e+04. What is the difference between the highest and the lowest Number of tourists of Liechtenstein?
Give a very brief answer. 1.30e+04. 